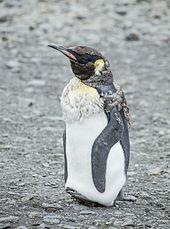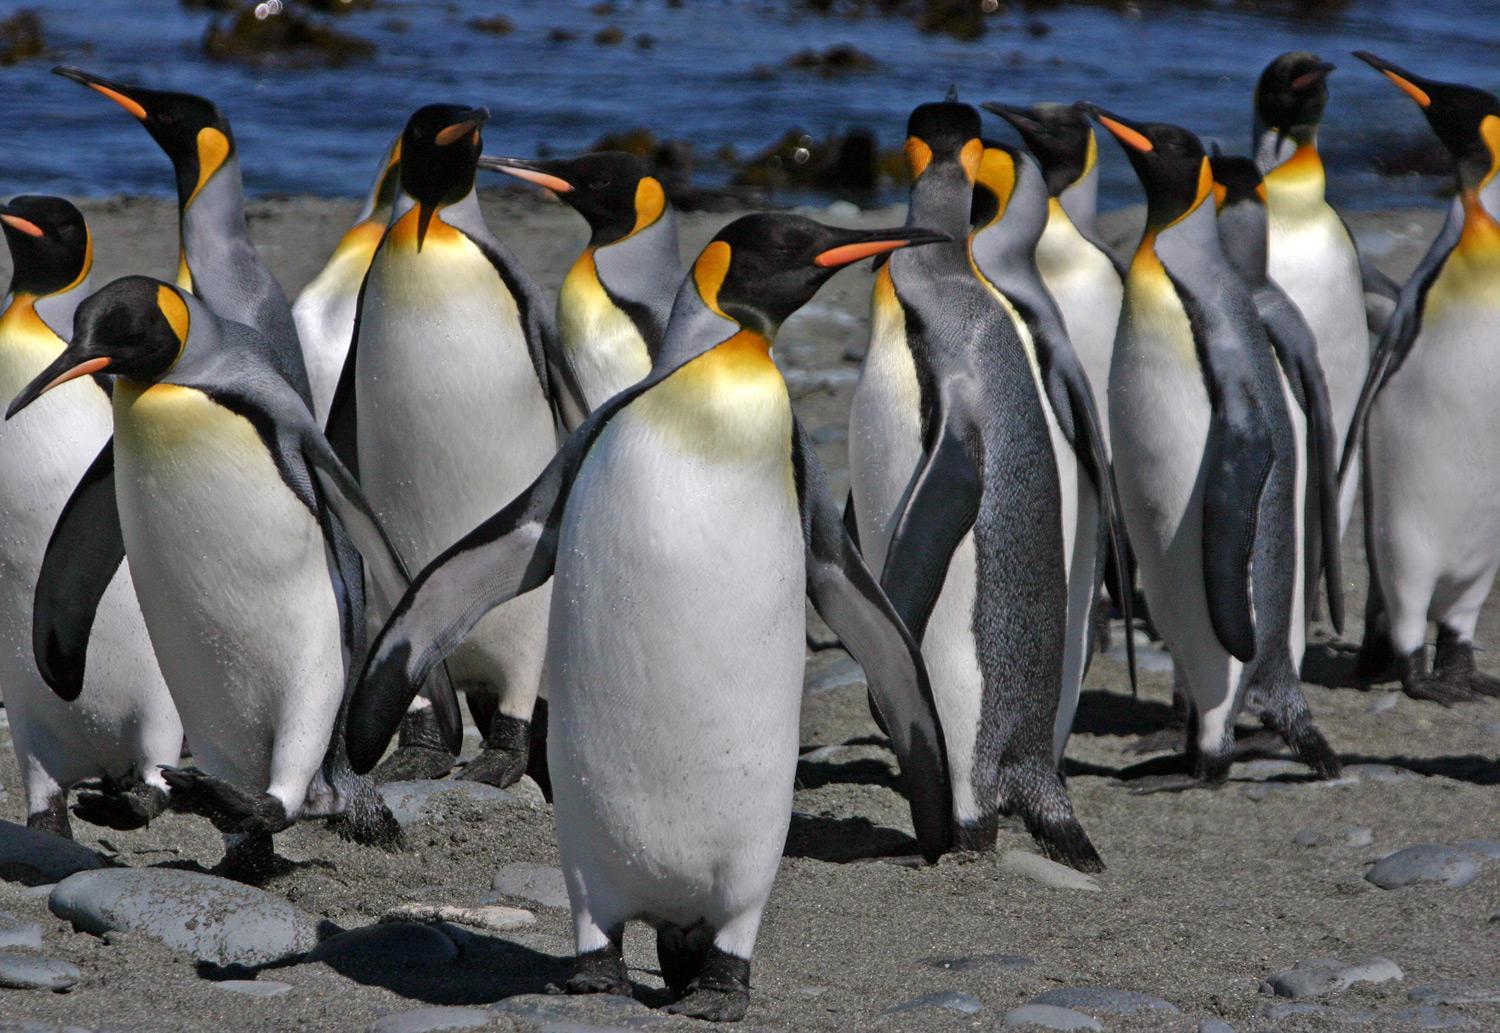The first image is the image on the left, the second image is the image on the right. For the images shown, is this caption "An image contains no more than two penguins, and includes a penguin with some fuzzy non-sleek feathers." true? Answer yes or no. Yes. The first image is the image on the left, the second image is the image on the right. Assess this claim about the two images: "There are no more than two penguins in the image on the left.". Correct or not? Answer yes or no. Yes. 